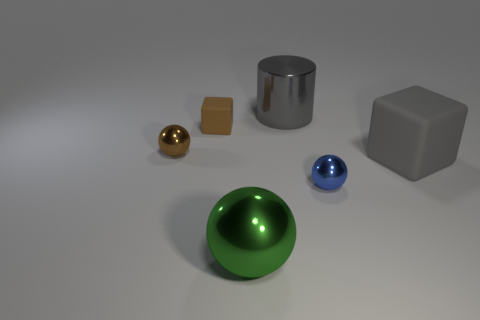Add 3 tiny red metallic cylinders. How many objects exist? 9 Subtract all cyan balls. Subtract all brown cylinders. How many balls are left? 3 Subtract all blocks. How many objects are left? 4 Add 1 brown cubes. How many brown cubes exist? 2 Subtract 0 red blocks. How many objects are left? 6 Subtract all tiny brown shiny things. Subtract all gray rubber blocks. How many objects are left? 4 Add 3 small brown objects. How many small brown objects are left? 5 